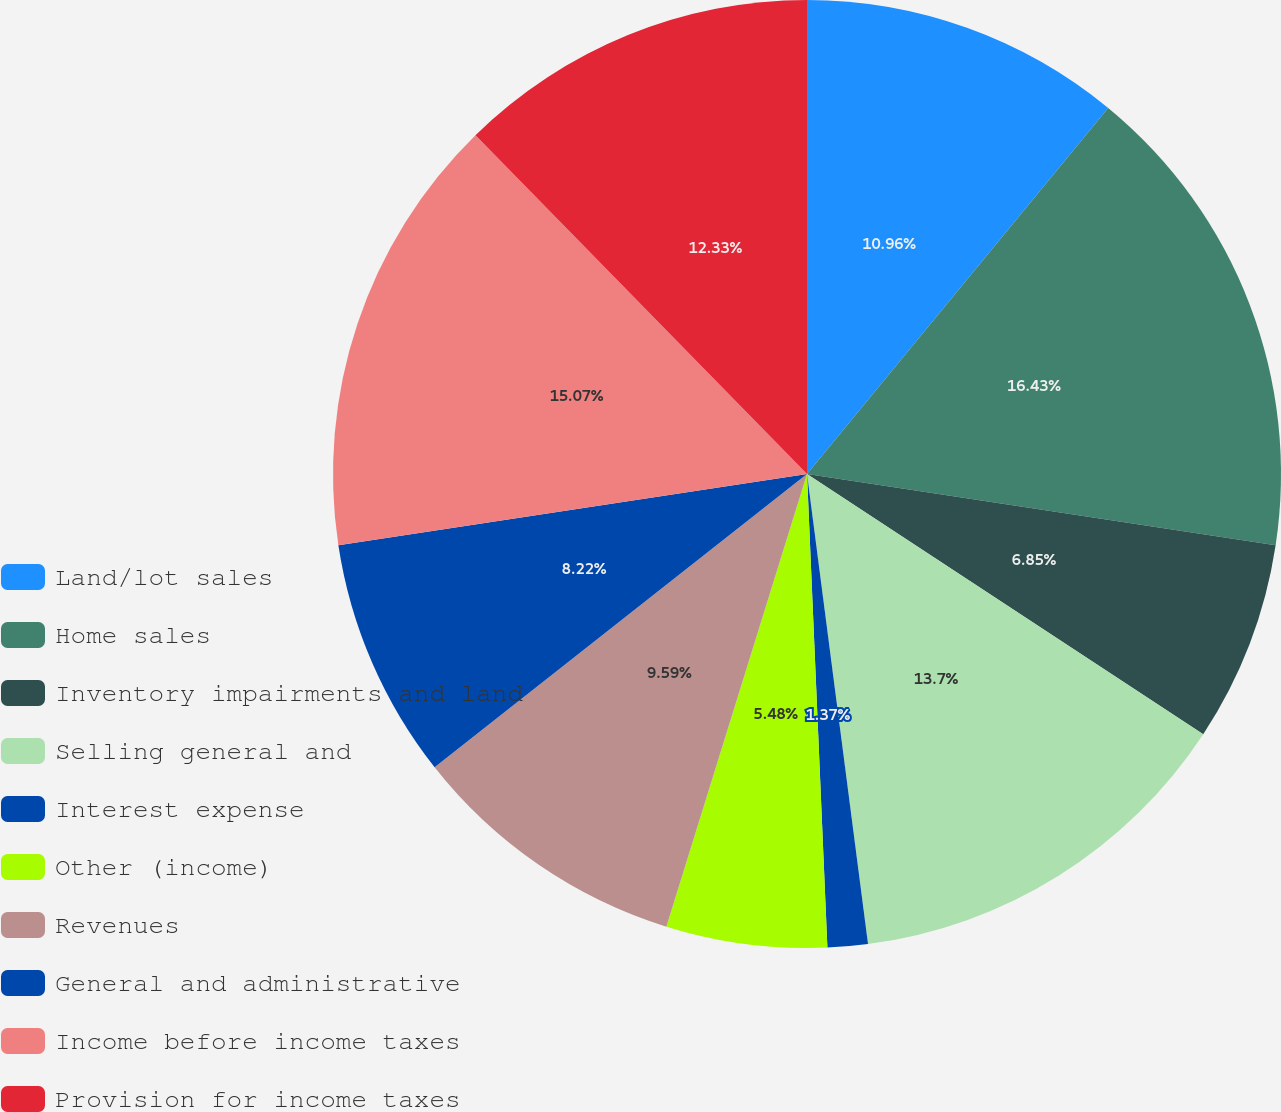<chart> <loc_0><loc_0><loc_500><loc_500><pie_chart><fcel>Land/lot sales<fcel>Home sales<fcel>Inventory impairments and land<fcel>Selling general and<fcel>Interest expense<fcel>Other (income)<fcel>Revenues<fcel>General and administrative<fcel>Income before income taxes<fcel>Provision for income taxes<nl><fcel>10.96%<fcel>16.44%<fcel>6.85%<fcel>13.7%<fcel>1.37%<fcel>5.48%<fcel>9.59%<fcel>8.22%<fcel>15.07%<fcel>12.33%<nl></chart> 